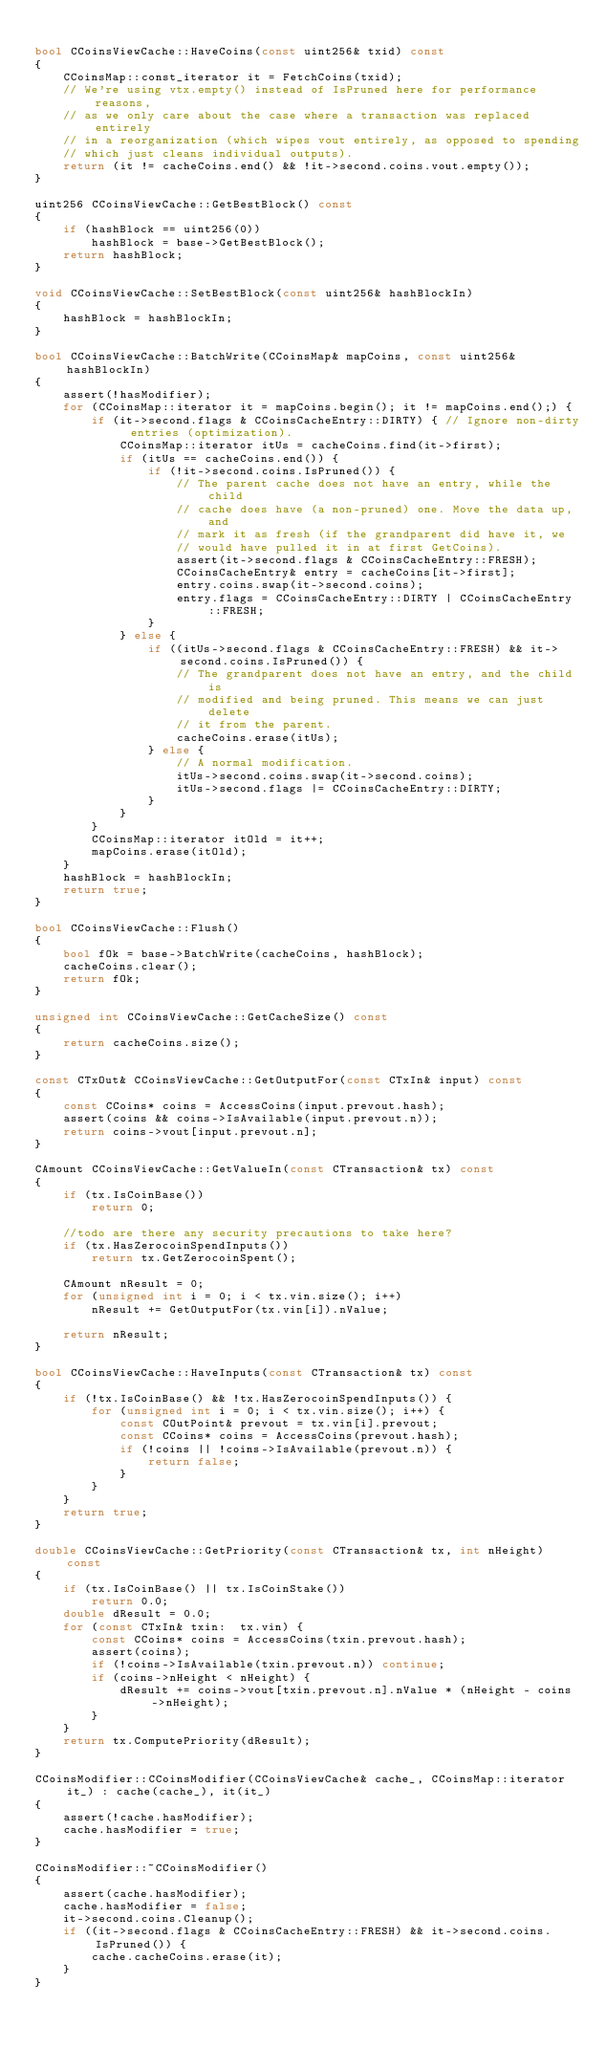Convert code to text. <code><loc_0><loc_0><loc_500><loc_500><_C++_>
bool CCoinsViewCache::HaveCoins(const uint256& txid) const
{
    CCoinsMap::const_iterator it = FetchCoins(txid);
    // We're using vtx.empty() instead of IsPruned here for performance reasons,
    // as we only care about the case where a transaction was replaced entirely
    // in a reorganization (which wipes vout entirely, as opposed to spending
    // which just cleans individual outputs).
    return (it != cacheCoins.end() && !it->second.coins.vout.empty());
}

uint256 CCoinsViewCache::GetBestBlock() const
{
    if (hashBlock == uint256(0))
        hashBlock = base->GetBestBlock();
    return hashBlock;
}

void CCoinsViewCache::SetBestBlock(const uint256& hashBlockIn)
{
    hashBlock = hashBlockIn;
}

bool CCoinsViewCache::BatchWrite(CCoinsMap& mapCoins, const uint256& hashBlockIn)
{
    assert(!hasModifier);
    for (CCoinsMap::iterator it = mapCoins.begin(); it != mapCoins.end();) {
        if (it->second.flags & CCoinsCacheEntry::DIRTY) { // Ignore non-dirty entries (optimization).
            CCoinsMap::iterator itUs = cacheCoins.find(it->first);
            if (itUs == cacheCoins.end()) {
                if (!it->second.coins.IsPruned()) {
                    // The parent cache does not have an entry, while the child
                    // cache does have (a non-pruned) one. Move the data up, and
                    // mark it as fresh (if the grandparent did have it, we
                    // would have pulled it in at first GetCoins).
                    assert(it->second.flags & CCoinsCacheEntry::FRESH);
                    CCoinsCacheEntry& entry = cacheCoins[it->first];
                    entry.coins.swap(it->second.coins);
                    entry.flags = CCoinsCacheEntry::DIRTY | CCoinsCacheEntry::FRESH;
                }
            } else {
                if ((itUs->second.flags & CCoinsCacheEntry::FRESH) && it->second.coins.IsPruned()) {
                    // The grandparent does not have an entry, and the child is
                    // modified and being pruned. This means we can just delete
                    // it from the parent.
                    cacheCoins.erase(itUs);
                } else {
                    // A normal modification.
                    itUs->second.coins.swap(it->second.coins);
                    itUs->second.flags |= CCoinsCacheEntry::DIRTY;
                }
            }
        }
        CCoinsMap::iterator itOld = it++;
        mapCoins.erase(itOld);
    }
    hashBlock = hashBlockIn;
    return true;
}

bool CCoinsViewCache::Flush()
{
    bool fOk = base->BatchWrite(cacheCoins, hashBlock);
    cacheCoins.clear();
    return fOk;
}

unsigned int CCoinsViewCache::GetCacheSize() const
{
    return cacheCoins.size();
}

const CTxOut& CCoinsViewCache::GetOutputFor(const CTxIn& input) const
{
    const CCoins* coins = AccessCoins(input.prevout.hash);
    assert(coins && coins->IsAvailable(input.prevout.n));
    return coins->vout[input.prevout.n];
}

CAmount CCoinsViewCache::GetValueIn(const CTransaction& tx) const
{
    if (tx.IsCoinBase())
        return 0;

    //todo are there any security precautions to take here?
    if (tx.HasZerocoinSpendInputs())
        return tx.GetZerocoinSpent();

    CAmount nResult = 0;
    for (unsigned int i = 0; i < tx.vin.size(); i++)
        nResult += GetOutputFor(tx.vin[i]).nValue;

    return nResult;
}

bool CCoinsViewCache::HaveInputs(const CTransaction& tx) const
{
    if (!tx.IsCoinBase() && !tx.HasZerocoinSpendInputs()) {
        for (unsigned int i = 0; i < tx.vin.size(); i++) {
            const COutPoint& prevout = tx.vin[i].prevout;
            const CCoins* coins = AccessCoins(prevout.hash);
            if (!coins || !coins->IsAvailable(prevout.n)) {
                return false;
            }
        }
    }
    return true;
}

double CCoinsViewCache::GetPriority(const CTransaction& tx, int nHeight) const
{
    if (tx.IsCoinBase() || tx.IsCoinStake())
        return 0.0;
    double dResult = 0.0;
    for (const CTxIn& txin:  tx.vin) {
        const CCoins* coins = AccessCoins(txin.prevout.hash);
        assert(coins);
        if (!coins->IsAvailable(txin.prevout.n)) continue;
        if (coins->nHeight < nHeight) {
            dResult += coins->vout[txin.prevout.n].nValue * (nHeight - coins->nHeight);
        }
    }
    return tx.ComputePriority(dResult);
}

CCoinsModifier::CCoinsModifier(CCoinsViewCache& cache_, CCoinsMap::iterator it_) : cache(cache_), it(it_)
{
    assert(!cache.hasModifier);
    cache.hasModifier = true;
}

CCoinsModifier::~CCoinsModifier()
{
    assert(cache.hasModifier);
    cache.hasModifier = false;
    it->second.coins.Cleanup();
    if ((it->second.flags & CCoinsCacheEntry::FRESH) && it->second.coins.IsPruned()) {
        cache.cacheCoins.erase(it);
    }
}
</code> 